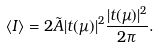Convert formula to latex. <formula><loc_0><loc_0><loc_500><loc_500>\langle I \rangle = 2 \tilde { A } | t ( \mu ) | ^ { 2 } \frac { | t ( \mu ) | ^ { 2 } } { 2 \pi } .</formula> 